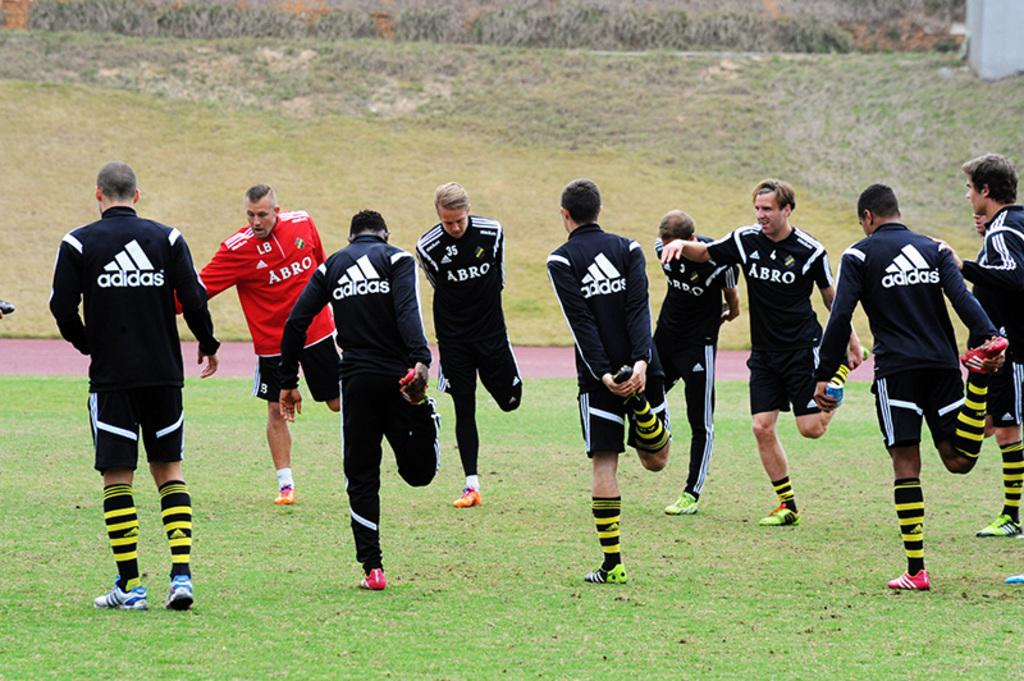<image>
Create a compact narrative representing the image presented. Several soccer players, wearing Adidas jackets, stretch their legs. 